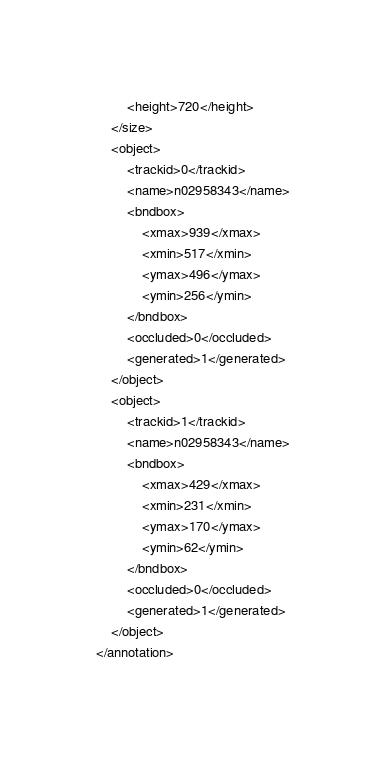<code> <loc_0><loc_0><loc_500><loc_500><_XML_>		<height>720</height>
	</size>
	<object>
		<trackid>0</trackid>
		<name>n02958343</name>
		<bndbox>
			<xmax>939</xmax>
			<xmin>517</xmin>
			<ymax>496</ymax>
			<ymin>256</ymin>
		</bndbox>
		<occluded>0</occluded>
		<generated>1</generated>
	</object>
	<object>
		<trackid>1</trackid>
		<name>n02958343</name>
		<bndbox>
			<xmax>429</xmax>
			<xmin>231</xmin>
			<ymax>170</ymax>
			<ymin>62</ymin>
		</bndbox>
		<occluded>0</occluded>
		<generated>1</generated>
	</object>
</annotation>
</code> 